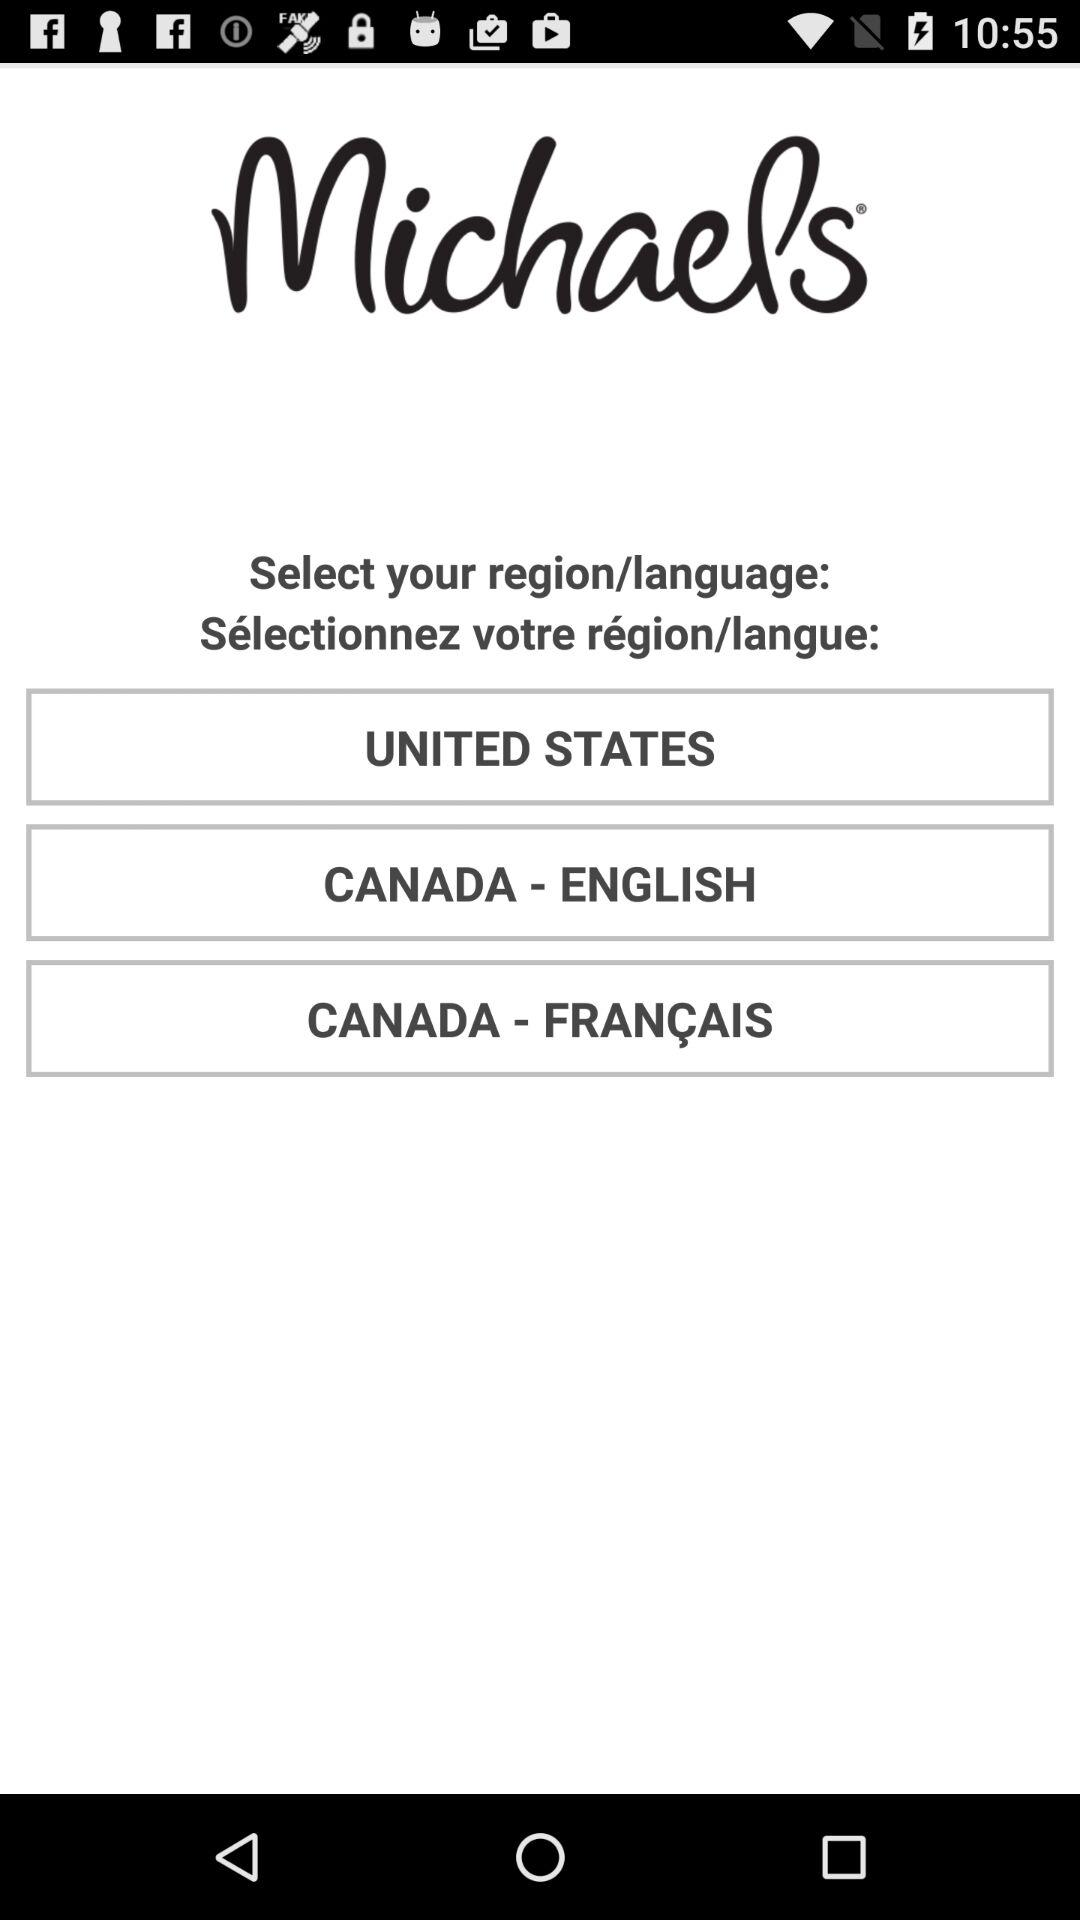English is selected for which country?
When the provided information is insufficient, respond with <no answer>. <no answer> 